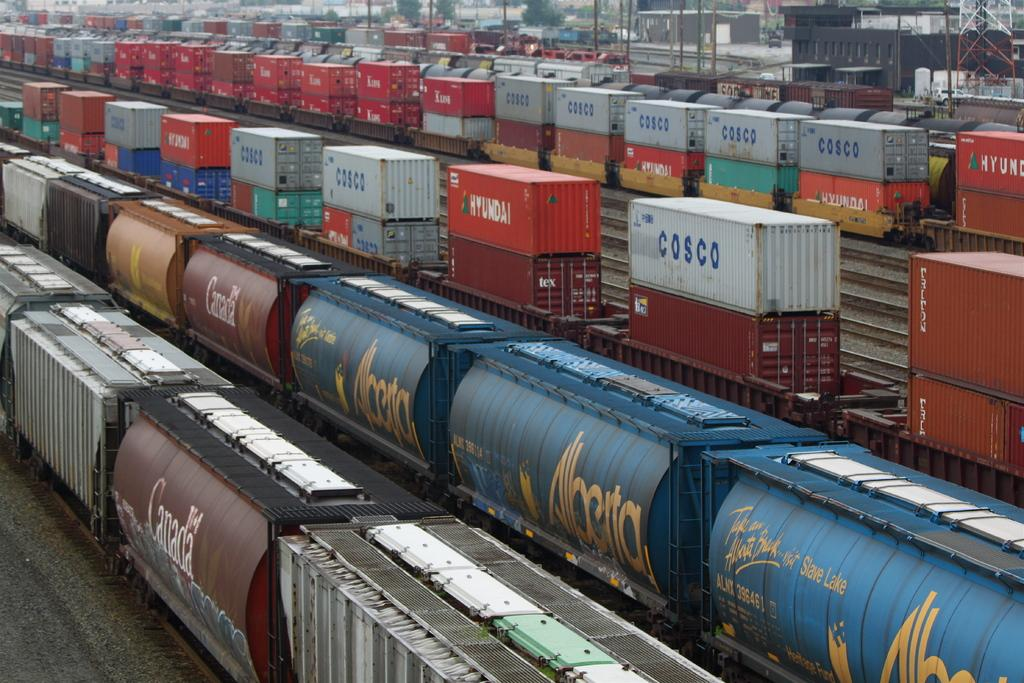<image>
Render a clear and concise summary of the photo. An industrial area with many Cosco shipping containers stacked up in rows. 